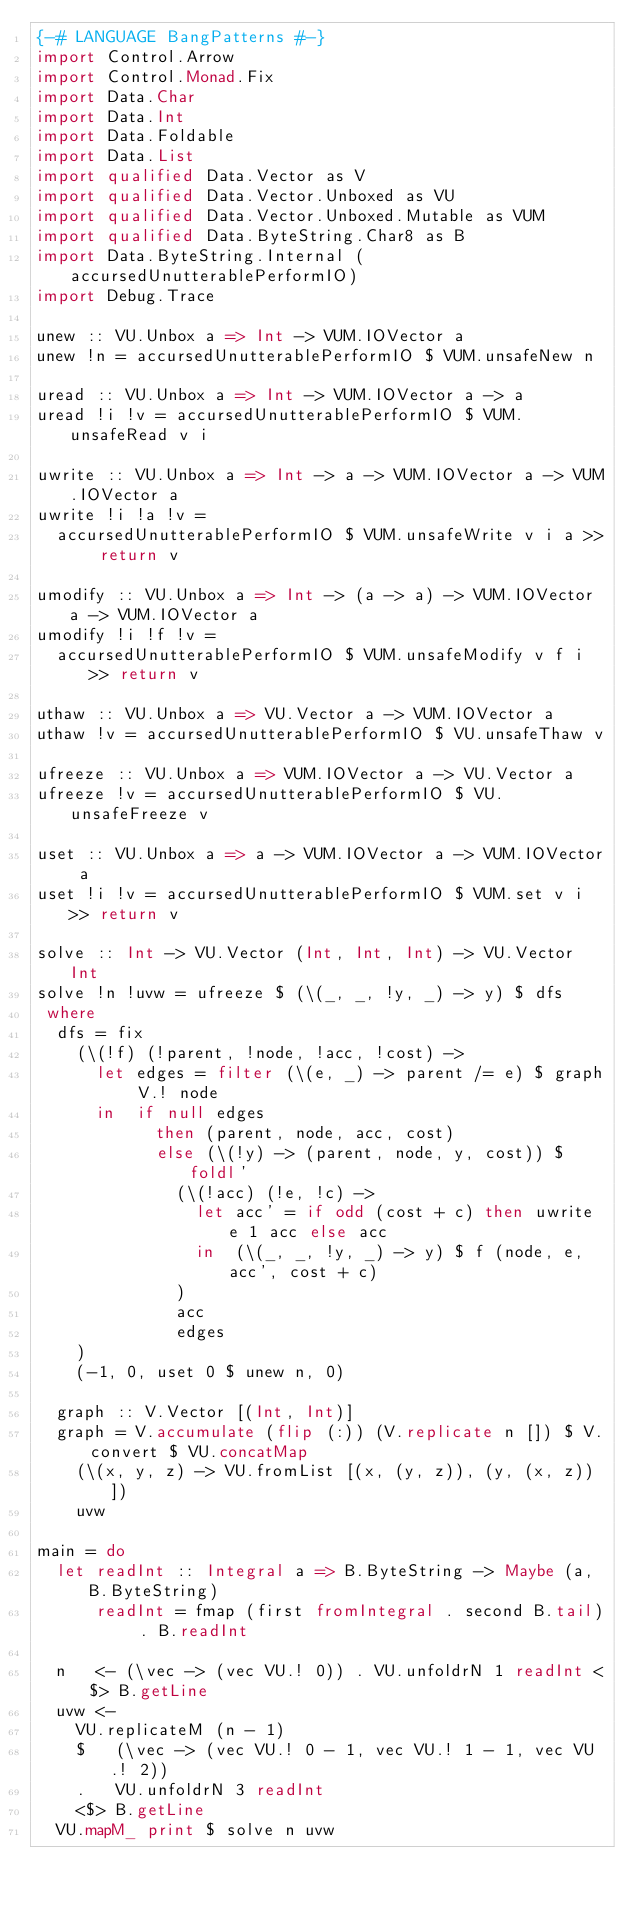<code> <loc_0><loc_0><loc_500><loc_500><_Haskell_>{-# LANGUAGE BangPatterns #-}
import Control.Arrow
import Control.Monad.Fix
import Data.Char
import Data.Int
import Data.Foldable
import Data.List
import qualified Data.Vector as V
import qualified Data.Vector.Unboxed as VU
import qualified Data.Vector.Unboxed.Mutable as VUM
import qualified Data.ByteString.Char8 as B
import Data.ByteString.Internal (accursedUnutterablePerformIO)
import Debug.Trace

unew :: VU.Unbox a => Int -> VUM.IOVector a
unew !n = accursedUnutterablePerformIO $ VUM.unsafeNew n

uread :: VU.Unbox a => Int -> VUM.IOVector a -> a
uread !i !v = accursedUnutterablePerformIO $ VUM.unsafeRead v i

uwrite :: VU.Unbox a => Int -> a -> VUM.IOVector a -> VUM.IOVector a
uwrite !i !a !v =
  accursedUnutterablePerformIO $ VUM.unsafeWrite v i a >> return v

umodify :: VU.Unbox a => Int -> (a -> a) -> VUM.IOVector a -> VUM.IOVector a
umodify !i !f !v =
  accursedUnutterablePerformIO $ VUM.unsafeModify v f i >> return v

uthaw :: VU.Unbox a => VU.Vector a -> VUM.IOVector a
uthaw !v = accursedUnutterablePerformIO $ VU.unsafeThaw v

ufreeze :: VU.Unbox a => VUM.IOVector a -> VU.Vector a
ufreeze !v = accursedUnutterablePerformIO $ VU.unsafeFreeze v

uset :: VU.Unbox a => a -> VUM.IOVector a -> VUM.IOVector a
uset !i !v = accursedUnutterablePerformIO $ VUM.set v i >> return v

solve :: Int -> VU.Vector (Int, Int, Int) -> VU.Vector Int
solve !n !uvw = ufreeze $ (\(_, _, !y, _) -> y) $ dfs
 where
  dfs = fix
    (\(!f) (!parent, !node, !acc, !cost) ->
      let edges = filter (\(e, _) -> parent /= e) $ graph V.! node
      in  if null edges
            then (parent, node, acc, cost)
            else (\(!y) -> (parent, node, y, cost)) $ foldl'
              (\(!acc) (!e, !c) ->
                let acc' = if odd (cost + c) then uwrite e 1 acc else acc
                in  (\(_, _, !y, _) -> y) $ f (node, e, acc', cost + c)
              )
              acc
              edges
    )
    (-1, 0, uset 0 $ unew n, 0)

  graph :: V.Vector [(Int, Int)]
  graph = V.accumulate (flip (:)) (V.replicate n []) $ V.convert $ VU.concatMap
    (\(x, y, z) -> VU.fromList [(x, (y, z)), (y, (x, z))])
    uvw

main = do
  let readInt :: Integral a => B.ByteString -> Maybe (a, B.ByteString)
      readInt = fmap (first fromIntegral . second B.tail) . B.readInt

  n   <- (\vec -> (vec VU.! 0)) . VU.unfoldrN 1 readInt <$> B.getLine
  uvw <-
    VU.replicateM (n - 1)
    $   (\vec -> (vec VU.! 0 - 1, vec VU.! 1 - 1, vec VU.! 2))
    .   VU.unfoldrN 3 readInt
    <$> B.getLine
  VU.mapM_ print $ solve n uvw
</code> 